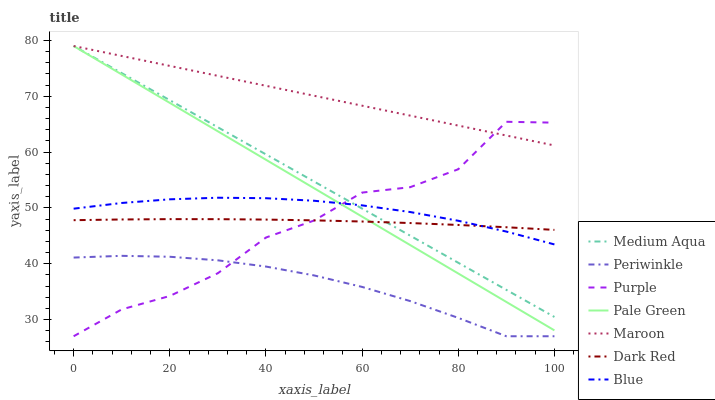Does Periwinkle have the minimum area under the curve?
Answer yes or no. Yes. Does Maroon have the maximum area under the curve?
Answer yes or no. Yes. Does Purple have the minimum area under the curve?
Answer yes or no. No. Does Purple have the maximum area under the curve?
Answer yes or no. No. Is Maroon the smoothest?
Answer yes or no. Yes. Is Purple the roughest?
Answer yes or no. Yes. Is Dark Red the smoothest?
Answer yes or no. No. Is Dark Red the roughest?
Answer yes or no. No. Does Purple have the lowest value?
Answer yes or no. Yes. Does Dark Red have the lowest value?
Answer yes or no. No. Does Medium Aqua have the highest value?
Answer yes or no. Yes. Does Purple have the highest value?
Answer yes or no. No. Is Periwinkle less than Blue?
Answer yes or no. Yes. Is Blue greater than Periwinkle?
Answer yes or no. Yes. Does Maroon intersect Purple?
Answer yes or no. Yes. Is Maroon less than Purple?
Answer yes or no. No. Is Maroon greater than Purple?
Answer yes or no. No. Does Periwinkle intersect Blue?
Answer yes or no. No. 